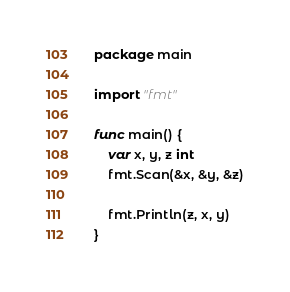<code> <loc_0><loc_0><loc_500><loc_500><_Go_>package main

import "fmt"

func main() {
	var x, y, z int
	fmt.Scan(&x, &y, &z)

	fmt.Println(z, x, y)
}
</code> 